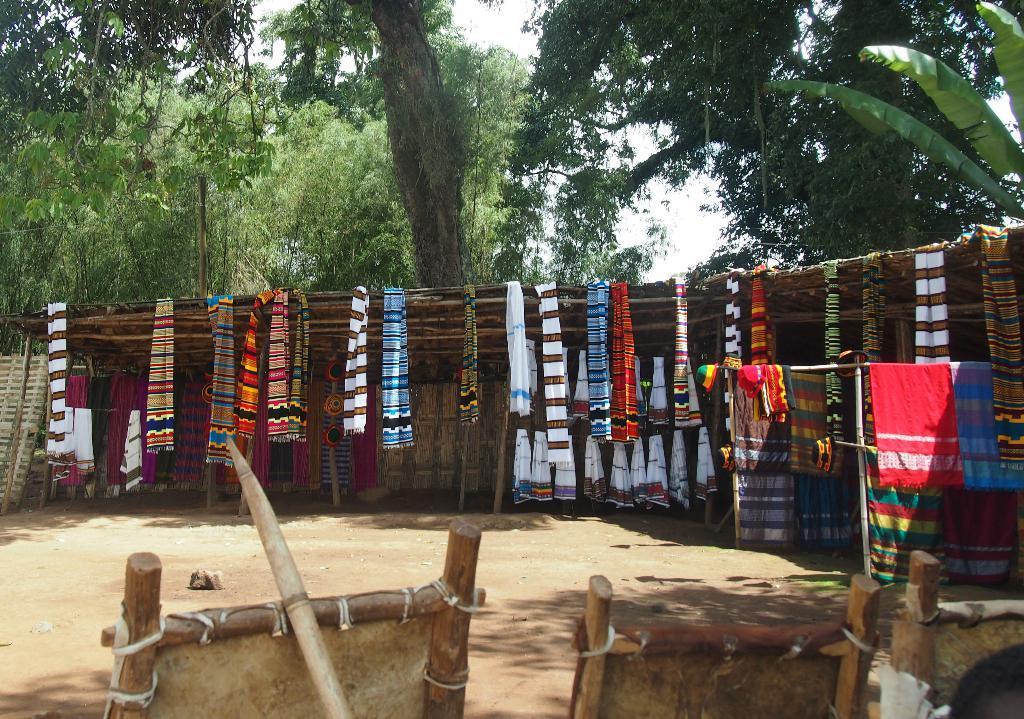How would you summarize this image in a sentence or two? In this image at the bottom there are wooden things. In the middle few clothes are hanged for drying. At the back side there are trees. 